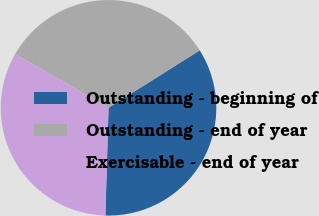Convert chart to OTSL. <chart><loc_0><loc_0><loc_500><loc_500><pie_chart><fcel>Outstanding - beginning of<fcel>Outstanding - end of year<fcel>Exercisable - end of year<nl><fcel>34.41%<fcel>32.71%<fcel>32.88%<nl></chart> 